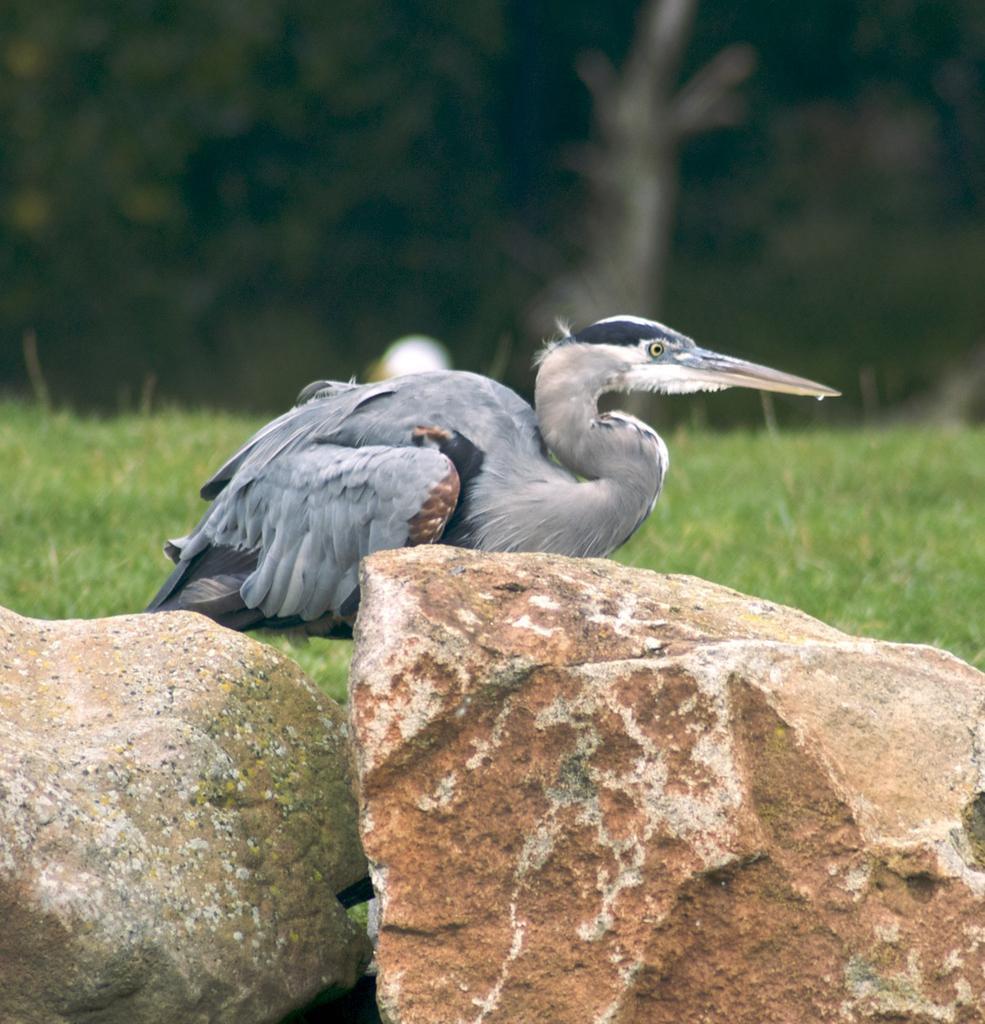How would you summarize this image in a sentence or two? We can see bird and stones. In the background we can see grass and it is blurry. 